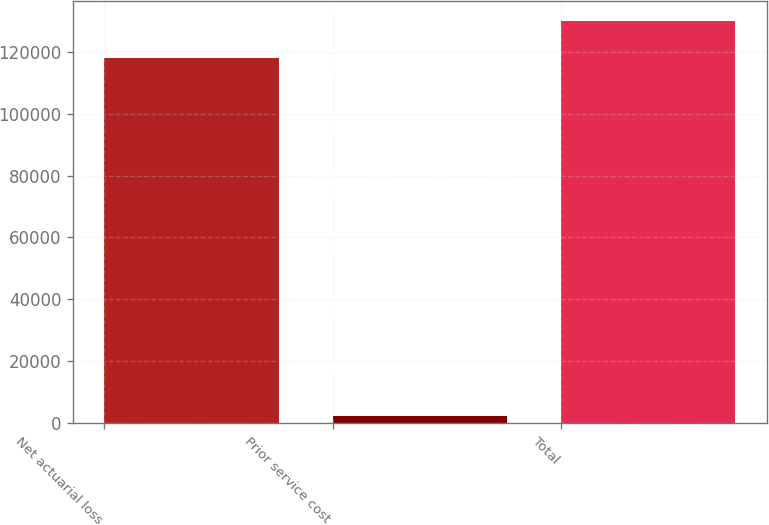Convert chart. <chart><loc_0><loc_0><loc_500><loc_500><bar_chart><fcel>Net actuarial loss<fcel>Prior service cost<fcel>Total<nl><fcel>118147<fcel>2154<fcel>129962<nl></chart> 